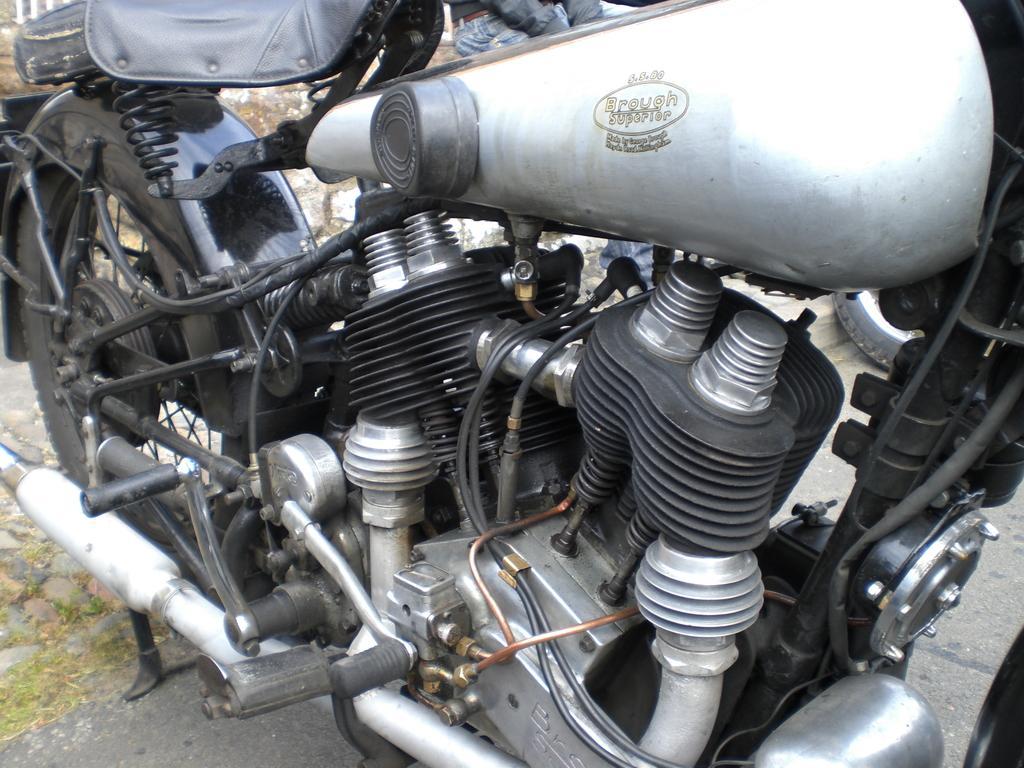Can you describe this image briefly? In this image, we can see motorbike and in the background, there is a person and at the bottom, there is a road. 